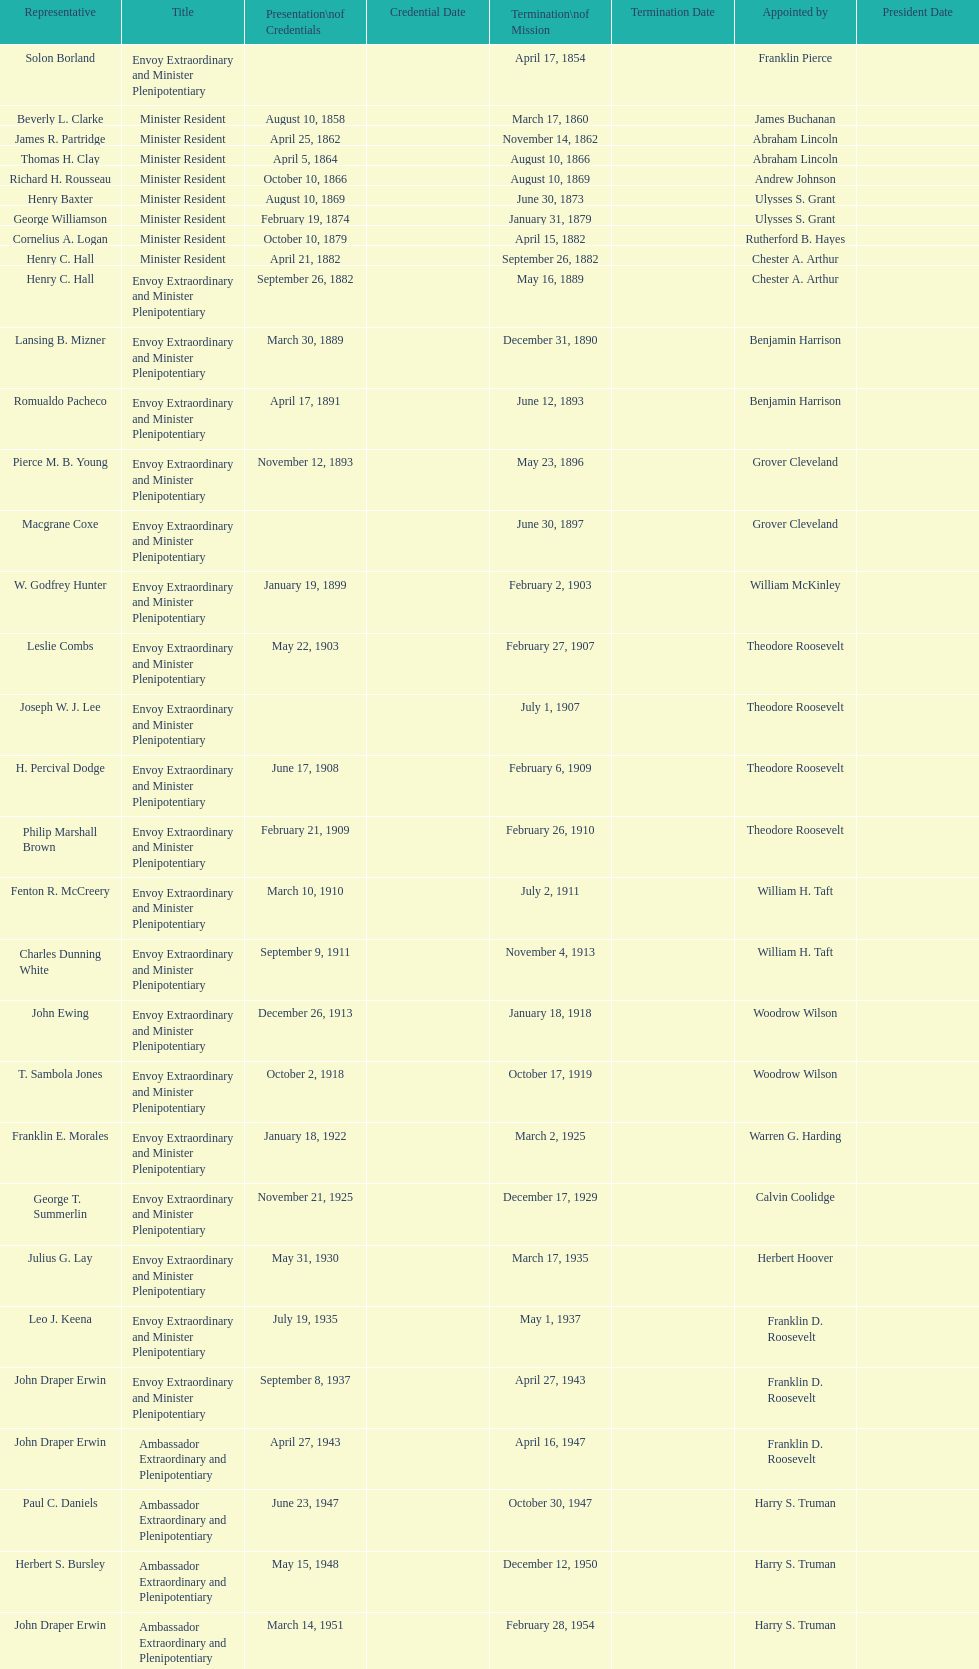Which ambassador to honduras served the longest term? Henry C. Hall. 